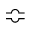Convert formula to latex. <formula><loc_0><loc_0><loc_500><loc_500>\ B u m p e q</formula> 